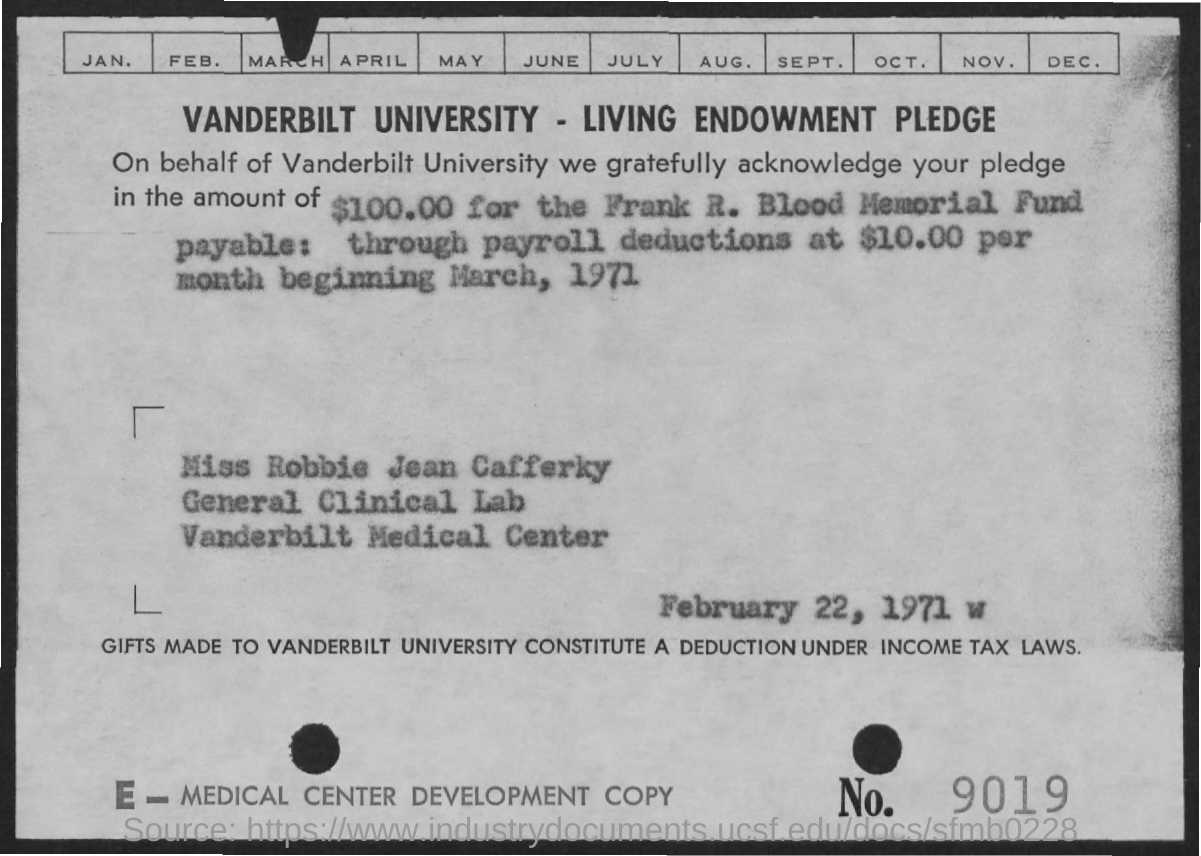What is the date mentioned in the given page ?
Give a very brief answer. February 22, 1971. 